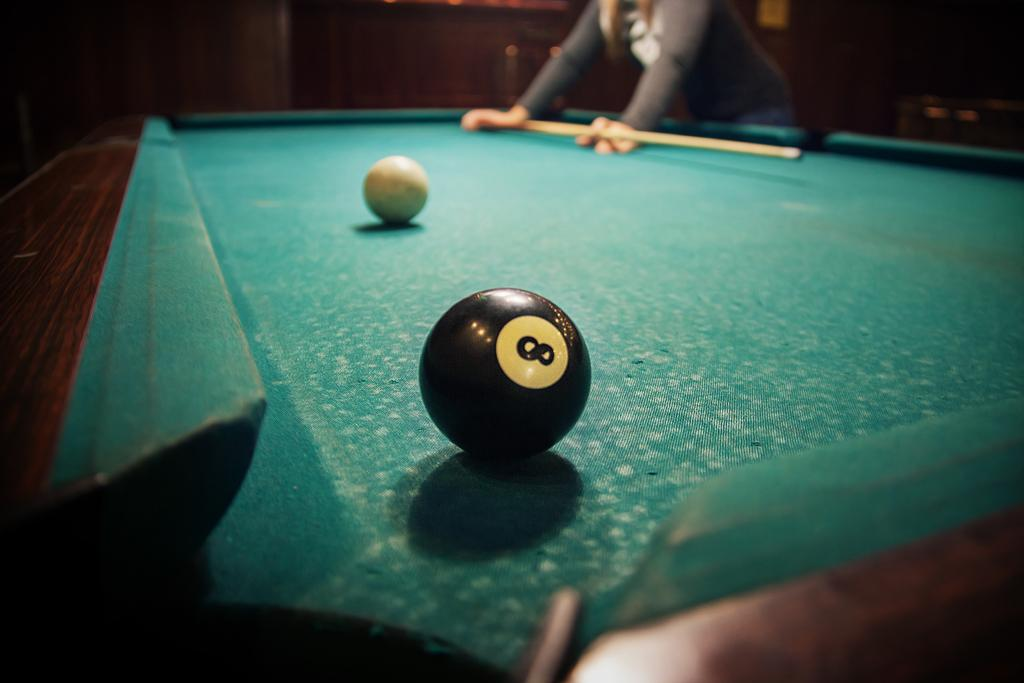What color is the table top in the image? The table top in the image is green. Who is present in the image? A man is standing in front of the table. What is the man holding in his hand? The man is holding something in his hand, but the specific object is not mentioned in the facts. What type of ball is on the table top? There is a white and black color ball on the table top. What type of brass instrument is the man playing in the image? There is no brass instrument or any indication of music playing in the image. 